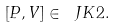Convert formula to latex. <formula><loc_0><loc_0><loc_500><loc_500>[ P , V ] \in \ J K { 2 } .</formula> 